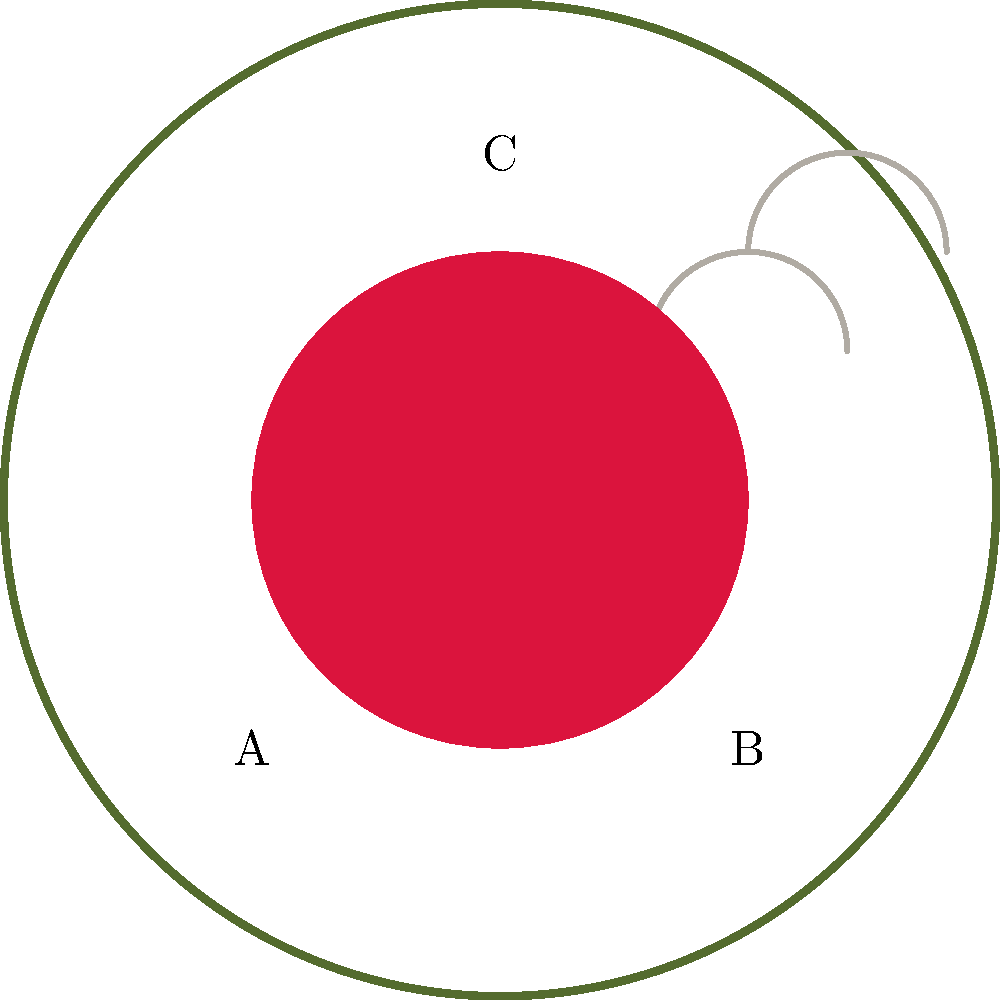In this illustration accompanying one of Petrarch's sonnets, which element symbolizes the poet's enduring love for Laura, as frequently portrayed in his works? To answer this question, we need to analyze the symbolism in the illustration:

1. Element A: Laurel wreath
   - The laurel wreath is a symbol of poetic achievement and fame.
   - In Petrarch's works, it often represents his pursuit of literary glory.

2. Element B: Heart
   - The heart is a universal symbol of love and passion.
   - In Petrarch's sonnets, it frequently represents his intense feelings for Laura.

3. Element C: Dove
   - The dove is often associated with peace, purity, and the Holy Spirit in Christian symbolism.
   - In Petrarch's poetry, it can represent Laura's purity or the divine nature of his love.

Among these elements, the heart (B) most directly symbolizes Petrarch's enduring love for Laura. Throughout his sonnets, Petrarch consistently portrays his love as intense, persistent, and unchanging, despite the passage of time and Laura's unavailability. The heart, as a timeless symbol of love, best encapsulates this central theme in Petrarch's work.

While the laurel wreath and dove are important symbols in Petrarch's poetry, they do not as directly represent his enduring love for Laura as the heart does.
Answer: The heart 